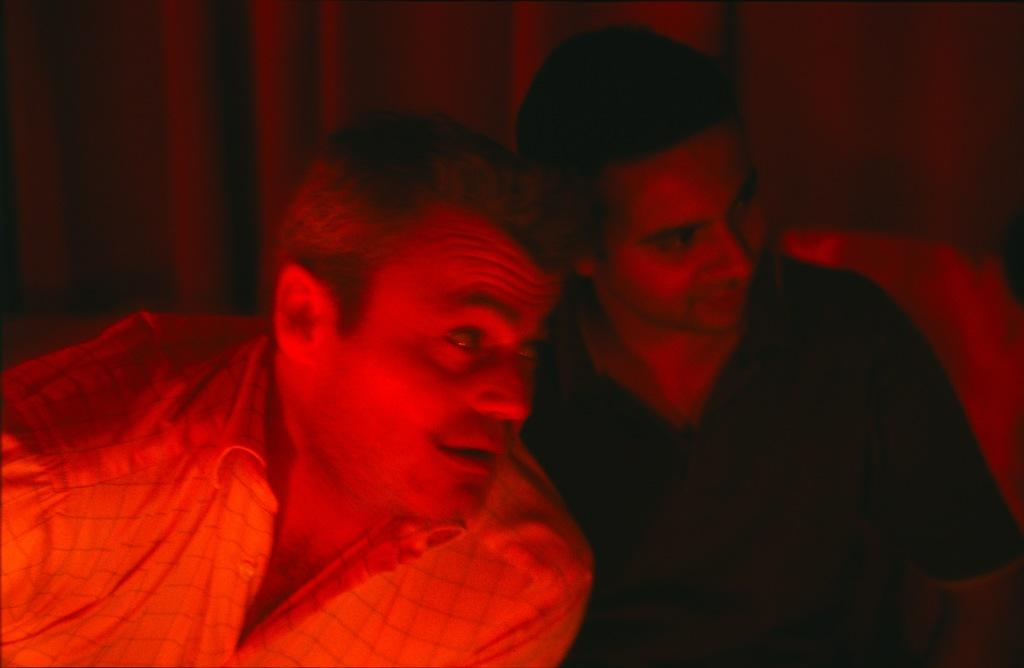How many people are in the foreground of the image? There are two men in the foreground of the image. What is the color of the light on the two men? The light on the two men is red. Can you describe the background of the image? The background of the image is not clear. Where is the shelf located in the image? There is no shelf present in the image. What type of wheel can be seen on the lawyer in the image? There is no lawyer or wheel present in the image. 